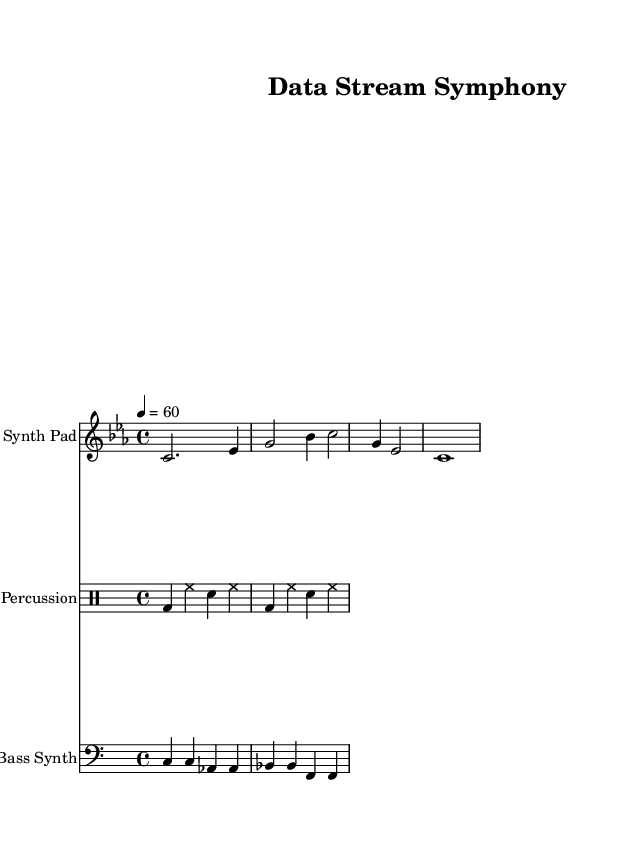What is the key signature of this music? The key signature is C minor, as indicated by the flat sign on the B line (which signifies B flat) and no additional accidentals.
Answer: C minor What is the time signature of this music? The time signature shown on the music is 4/4, which means there are four beats in each measure and the quarter note gets one beat.
Answer: 4/4 What is the tempo marking indicated in this music? The tempo marking is 60 beats per minute, as indicated by the '4 = 60' instruction placed above the staff, which signifies the metrical speed.
Answer: 60 How many instruments are present in this score? There are three instruments listed in this score: Synth Pad, Percussion, and Bass Synth. This is determined by counting the distinct staves and their instrument names provided in the score layout.
Answer: Three What type of rhythm does the percussion section use? The percussion section uses a steady pattern comprising bass drums and hi-hats, which is characteristic of electronic music influences, providing a consistent foundational beat.
Answer: Steady pattern What is the main characteristic of the bass line in this music? The bass line features repeated notes, creating a drone-like effect that is typical in ambient music, contributing to an evolving soundscape.
Answer: Repeated notes What mood or atmosphere does this music aim to evoke? The music aims to evoke an ambient, serene, and contemplative atmosphere, as indicated by the slow tempo, soft dynamics, and the nature of sound textures used in the composition.
Answer: Ambient 